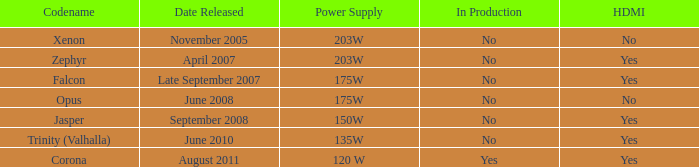Is Jasper being producted? No. 